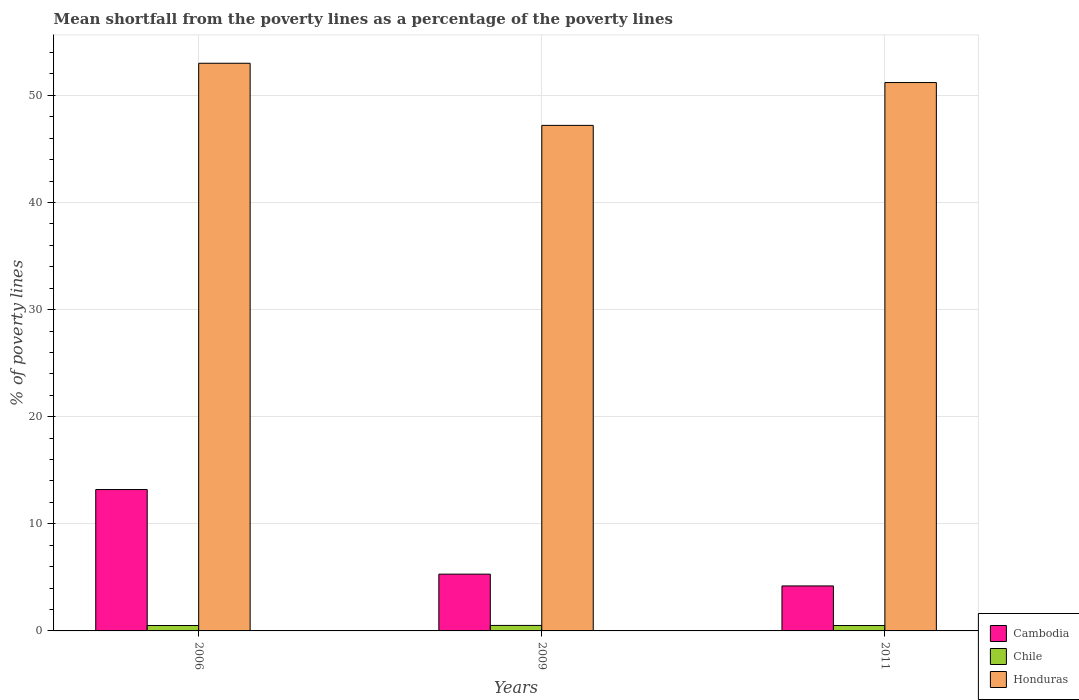How many bars are there on the 1st tick from the left?
Provide a short and direct response. 3. What is the label of the 2nd group of bars from the left?
Keep it short and to the point. 2009. In how many cases, is the number of bars for a given year not equal to the number of legend labels?
Provide a succinct answer. 0. What is the mean shortfall from the poverty lines as a percentage of the poverty lines in Honduras in 2009?
Keep it short and to the point. 47.2. Across all years, what is the maximum mean shortfall from the poverty lines as a percentage of the poverty lines in Cambodia?
Your response must be concise. 13.2. Across all years, what is the minimum mean shortfall from the poverty lines as a percentage of the poverty lines in Chile?
Make the answer very short. 0.5. In which year was the mean shortfall from the poverty lines as a percentage of the poverty lines in Cambodia maximum?
Give a very brief answer. 2006. What is the total mean shortfall from the poverty lines as a percentage of the poverty lines in Honduras in the graph?
Provide a short and direct response. 151.4. What is the difference between the mean shortfall from the poverty lines as a percentage of the poverty lines in Honduras in 2006 and that in 2011?
Keep it short and to the point. 1.8. What is the difference between the mean shortfall from the poverty lines as a percentage of the poverty lines in Chile in 2011 and the mean shortfall from the poverty lines as a percentage of the poverty lines in Cambodia in 2006?
Keep it short and to the point. -12.7. What is the average mean shortfall from the poverty lines as a percentage of the poverty lines in Honduras per year?
Offer a very short reply. 50.47. In the year 2006, what is the difference between the mean shortfall from the poverty lines as a percentage of the poverty lines in Cambodia and mean shortfall from the poverty lines as a percentage of the poverty lines in Honduras?
Make the answer very short. -39.8. In how many years, is the mean shortfall from the poverty lines as a percentage of the poverty lines in Cambodia greater than 28 %?
Your response must be concise. 0. What is the ratio of the mean shortfall from the poverty lines as a percentage of the poverty lines in Chile in 2006 to that in 2009?
Your answer should be compact. 0.99. Is the difference between the mean shortfall from the poverty lines as a percentage of the poverty lines in Cambodia in 2009 and 2011 greater than the difference between the mean shortfall from the poverty lines as a percentage of the poverty lines in Honduras in 2009 and 2011?
Your response must be concise. Yes. What is the difference between the highest and the second highest mean shortfall from the poverty lines as a percentage of the poverty lines in Honduras?
Ensure brevity in your answer.  1.8. What is the difference between the highest and the lowest mean shortfall from the poverty lines as a percentage of the poverty lines in Chile?
Your answer should be compact. 0.01. Is the sum of the mean shortfall from the poverty lines as a percentage of the poverty lines in Chile in 2009 and 2011 greater than the maximum mean shortfall from the poverty lines as a percentage of the poverty lines in Honduras across all years?
Give a very brief answer. No. What does the 1st bar from the left in 2009 represents?
Your answer should be compact. Cambodia. How many bars are there?
Your answer should be compact. 9. Are all the bars in the graph horizontal?
Provide a short and direct response. No. What is the difference between two consecutive major ticks on the Y-axis?
Provide a short and direct response. 10. Are the values on the major ticks of Y-axis written in scientific E-notation?
Provide a succinct answer. No. Does the graph contain any zero values?
Offer a very short reply. No. How many legend labels are there?
Offer a very short reply. 3. What is the title of the graph?
Provide a short and direct response. Mean shortfall from the poverty lines as a percentage of the poverty lines. What is the label or title of the X-axis?
Offer a very short reply. Years. What is the label or title of the Y-axis?
Ensure brevity in your answer.  % of poverty lines. What is the % of poverty lines in Chile in 2006?
Provide a succinct answer. 0.51. What is the % of poverty lines of Honduras in 2006?
Keep it short and to the point. 53. What is the % of poverty lines in Cambodia in 2009?
Offer a very short reply. 5.3. What is the % of poverty lines in Chile in 2009?
Offer a very short reply. 0.51. What is the % of poverty lines of Honduras in 2009?
Offer a terse response. 47.2. What is the % of poverty lines of Cambodia in 2011?
Provide a succinct answer. 4.2. What is the % of poverty lines of Chile in 2011?
Provide a succinct answer. 0.5. What is the % of poverty lines in Honduras in 2011?
Give a very brief answer. 51.2. Across all years, what is the maximum % of poverty lines in Cambodia?
Provide a short and direct response. 13.2. Across all years, what is the maximum % of poverty lines in Chile?
Your answer should be very brief. 0.51. Across all years, what is the minimum % of poverty lines in Chile?
Your answer should be compact. 0.5. Across all years, what is the minimum % of poverty lines of Honduras?
Give a very brief answer. 47.2. What is the total % of poverty lines of Cambodia in the graph?
Offer a terse response. 22.7. What is the total % of poverty lines of Chile in the graph?
Ensure brevity in your answer.  1.52. What is the total % of poverty lines in Honduras in the graph?
Your answer should be very brief. 151.4. What is the difference between the % of poverty lines in Cambodia in 2006 and that in 2009?
Make the answer very short. 7.9. What is the difference between the % of poverty lines in Chile in 2006 and that in 2009?
Offer a terse response. -0.01. What is the difference between the % of poverty lines of Chile in 2006 and that in 2011?
Provide a succinct answer. 0. What is the difference between the % of poverty lines in Cambodia in 2009 and that in 2011?
Give a very brief answer. 1.1. What is the difference between the % of poverty lines in Chile in 2009 and that in 2011?
Your answer should be very brief. 0.01. What is the difference between the % of poverty lines in Cambodia in 2006 and the % of poverty lines in Chile in 2009?
Your answer should be very brief. 12.69. What is the difference between the % of poverty lines of Cambodia in 2006 and the % of poverty lines of Honduras in 2009?
Your response must be concise. -34. What is the difference between the % of poverty lines in Chile in 2006 and the % of poverty lines in Honduras in 2009?
Ensure brevity in your answer.  -46.7. What is the difference between the % of poverty lines in Cambodia in 2006 and the % of poverty lines in Chile in 2011?
Your answer should be very brief. 12.7. What is the difference between the % of poverty lines of Cambodia in 2006 and the % of poverty lines of Honduras in 2011?
Provide a succinct answer. -38. What is the difference between the % of poverty lines in Chile in 2006 and the % of poverty lines in Honduras in 2011?
Offer a very short reply. -50.7. What is the difference between the % of poverty lines of Cambodia in 2009 and the % of poverty lines of Chile in 2011?
Your answer should be very brief. 4.8. What is the difference between the % of poverty lines in Cambodia in 2009 and the % of poverty lines in Honduras in 2011?
Keep it short and to the point. -45.9. What is the difference between the % of poverty lines in Chile in 2009 and the % of poverty lines in Honduras in 2011?
Your answer should be compact. -50.69. What is the average % of poverty lines of Cambodia per year?
Your answer should be very brief. 7.57. What is the average % of poverty lines in Chile per year?
Make the answer very short. 0.51. What is the average % of poverty lines of Honduras per year?
Your answer should be compact. 50.47. In the year 2006, what is the difference between the % of poverty lines in Cambodia and % of poverty lines in Chile?
Give a very brief answer. 12.7. In the year 2006, what is the difference between the % of poverty lines of Cambodia and % of poverty lines of Honduras?
Your answer should be very brief. -39.8. In the year 2006, what is the difference between the % of poverty lines of Chile and % of poverty lines of Honduras?
Make the answer very short. -52.49. In the year 2009, what is the difference between the % of poverty lines in Cambodia and % of poverty lines in Chile?
Provide a succinct answer. 4.79. In the year 2009, what is the difference between the % of poverty lines in Cambodia and % of poverty lines in Honduras?
Offer a terse response. -41.9. In the year 2009, what is the difference between the % of poverty lines of Chile and % of poverty lines of Honduras?
Offer a terse response. -46.69. In the year 2011, what is the difference between the % of poverty lines in Cambodia and % of poverty lines in Chile?
Ensure brevity in your answer.  3.7. In the year 2011, what is the difference between the % of poverty lines in Cambodia and % of poverty lines in Honduras?
Make the answer very short. -47. In the year 2011, what is the difference between the % of poverty lines in Chile and % of poverty lines in Honduras?
Keep it short and to the point. -50.7. What is the ratio of the % of poverty lines of Cambodia in 2006 to that in 2009?
Your answer should be very brief. 2.49. What is the ratio of the % of poverty lines of Chile in 2006 to that in 2009?
Provide a short and direct response. 0.99. What is the ratio of the % of poverty lines of Honduras in 2006 to that in 2009?
Make the answer very short. 1.12. What is the ratio of the % of poverty lines of Cambodia in 2006 to that in 2011?
Your response must be concise. 3.14. What is the ratio of the % of poverty lines in Honduras in 2006 to that in 2011?
Offer a terse response. 1.04. What is the ratio of the % of poverty lines of Cambodia in 2009 to that in 2011?
Your answer should be very brief. 1.26. What is the ratio of the % of poverty lines in Chile in 2009 to that in 2011?
Make the answer very short. 1.02. What is the ratio of the % of poverty lines in Honduras in 2009 to that in 2011?
Make the answer very short. 0.92. What is the difference between the highest and the second highest % of poverty lines in Chile?
Your answer should be very brief. 0.01. What is the difference between the highest and the lowest % of poverty lines of Chile?
Keep it short and to the point. 0.01. What is the difference between the highest and the lowest % of poverty lines of Honduras?
Give a very brief answer. 5.8. 